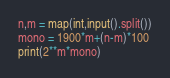<code> <loc_0><loc_0><loc_500><loc_500><_Python_>n,m = map(int,input().split())
mono = 1900*m+(n-m)*100
print(2**m*mono)</code> 